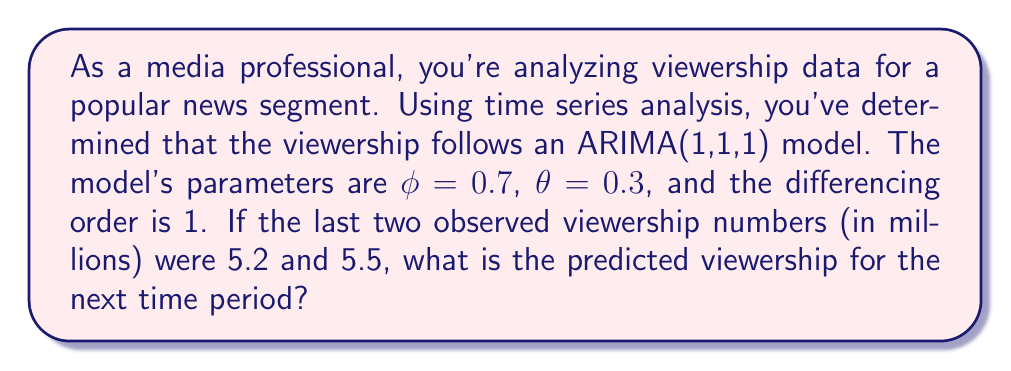Can you answer this question? Let's approach this step-by-step:

1) The ARIMA(1,1,1) model can be written as:

   $$(1 - \phi B)(1 - B)y_t = (1 + \theta B)\epsilon_t$$

   where $B$ is the backshift operator.

2) Expanding this, we get:

   $$y_t - (1 + \phi)y_{t-1} + \phi y_{t-2} = \epsilon_t + \theta \epsilon_{t-1}$$

3) Rearranging to isolate $y_t$:

   $$y_t = (1 + \phi)y_{t-1} - \phi y_{t-2} + \epsilon_t + \theta \epsilon_{t-1}$$

4) We're given $\phi = 0.7$ and $\theta = 0.3$. Substituting these:

   $$y_t = 1.7y_{t-1} - 0.7y_{t-2} + \epsilon_t + 0.3\epsilon_{t-1}$$

5) We know the last two viewership numbers: $y_{t-1} = 5.5$ and $y_{t-2} = 5.2$

6) For forecasting one step ahead, we set future error terms to their expected value of 0:

   $$\hat{y}_t = 1.7(5.5) - 0.7(5.2) + 0 + 0$$

7) Calculating:

   $$\hat{y}_t = 9.35 - 3.64 = 5.71$$

Therefore, the predicted viewership for the next time period is 5.71 million.
Answer: 5.71 million viewers 